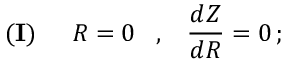Convert formula to latex. <formula><loc_0><loc_0><loc_500><loc_500>{ ( I ) } \, R = 0 \, , \, \frac { d Z } { d R } = 0 \, ;</formula> 